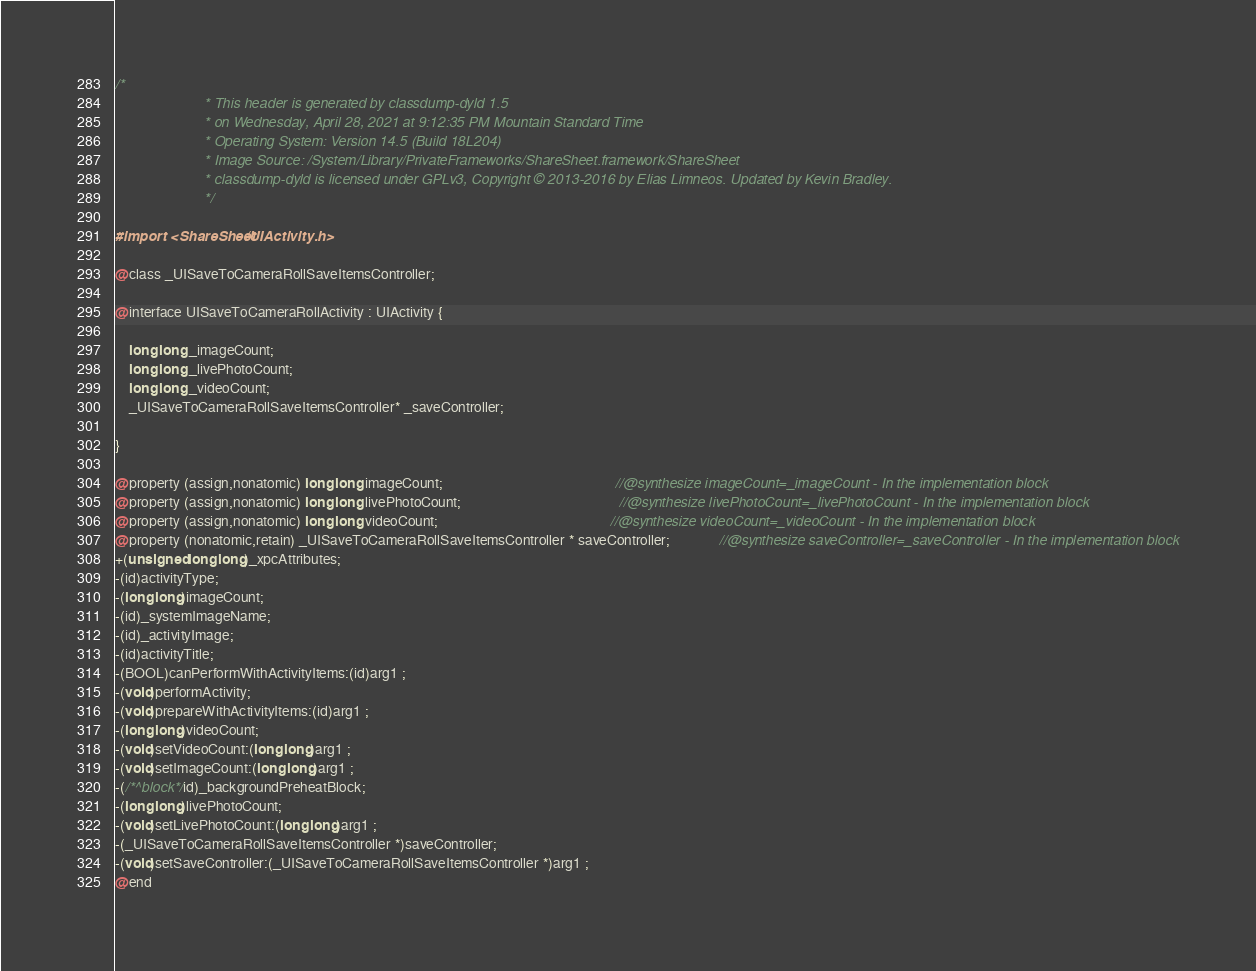Convert code to text. <code><loc_0><loc_0><loc_500><loc_500><_C_>/*
                       * This header is generated by classdump-dyld 1.5
                       * on Wednesday, April 28, 2021 at 9:12:35 PM Mountain Standard Time
                       * Operating System: Version 14.5 (Build 18L204)
                       * Image Source: /System/Library/PrivateFrameworks/ShareSheet.framework/ShareSheet
                       * classdump-dyld is licensed under GPLv3, Copyright © 2013-2016 by Elias Limneos. Updated by Kevin Bradley.
                       */

#import <ShareSheet/UIActivity.h>

@class _UISaveToCameraRollSaveItemsController;

@interface UISaveToCameraRollActivity : UIActivity {

	long long _imageCount;
	long long _livePhotoCount;
	long long _videoCount;
	_UISaveToCameraRollSaveItemsController* _saveController;

}

@property (assign,nonatomic) long long imageCount;                                                 //@synthesize imageCount=_imageCount - In the implementation block
@property (assign,nonatomic) long long livePhotoCount;                                             //@synthesize livePhotoCount=_livePhotoCount - In the implementation block
@property (assign,nonatomic) long long videoCount;                                                 //@synthesize videoCount=_videoCount - In the implementation block
@property (nonatomic,retain) _UISaveToCameraRollSaveItemsController * saveController;              //@synthesize saveController=_saveController - In the implementation block
+(unsigned long long)_xpcAttributes;
-(id)activityType;
-(long long)imageCount;
-(id)_systemImageName;
-(id)_activityImage;
-(id)activityTitle;
-(BOOL)canPerformWithActivityItems:(id)arg1 ;
-(void)performActivity;
-(void)prepareWithActivityItems:(id)arg1 ;
-(long long)videoCount;
-(void)setVideoCount:(long long)arg1 ;
-(void)setImageCount:(long long)arg1 ;
-(/*^block*/id)_backgroundPreheatBlock;
-(long long)livePhotoCount;
-(void)setLivePhotoCount:(long long)arg1 ;
-(_UISaveToCameraRollSaveItemsController *)saveController;
-(void)setSaveController:(_UISaveToCameraRollSaveItemsController *)arg1 ;
@end

</code> 